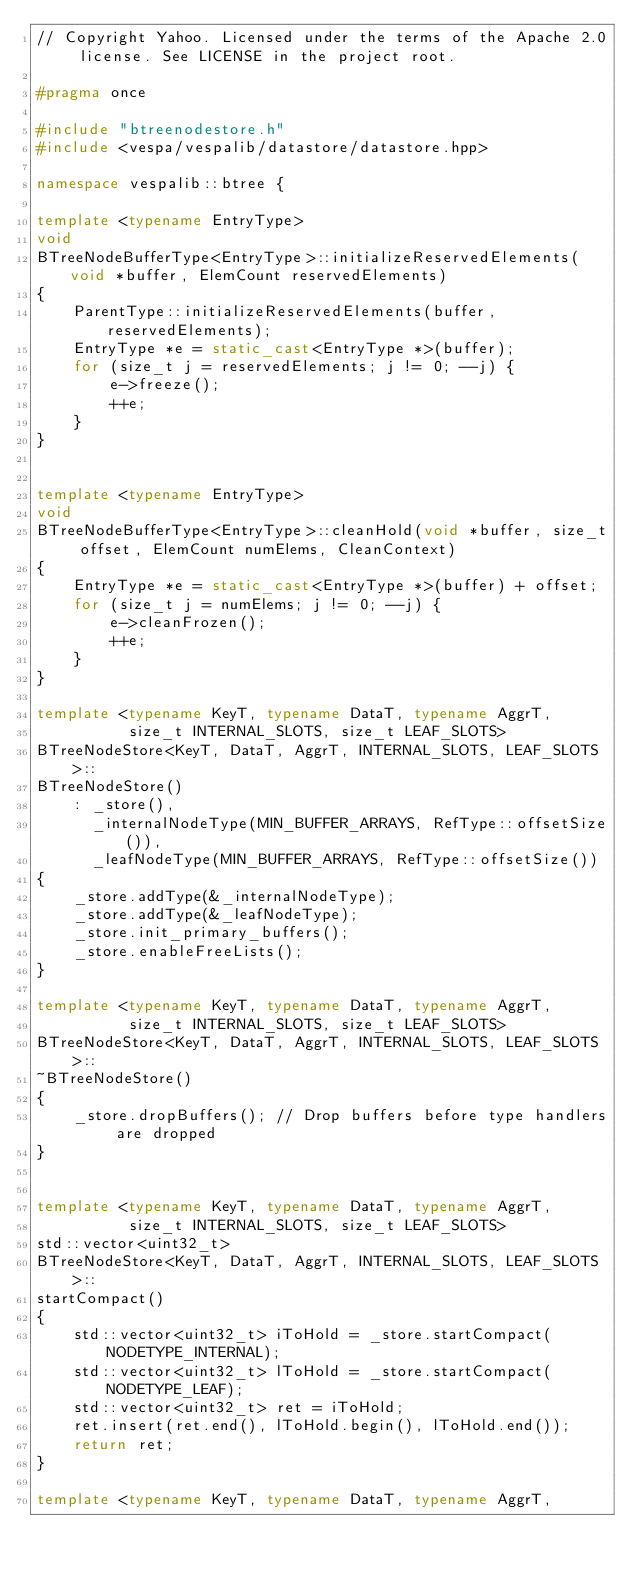Convert code to text. <code><loc_0><loc_0><loc_500><loc_500><_C++_>// Copyright Yahoo. Licensed under the terms of the Apache 2.0 license. See LICENSE in the project root.

#pragma once

#include "btreenodestore.h"
#include <vespa/vespalib/datastore/datastore.hpp>

namespace vespalib::btree {

template <typename EntryType>
void
BTreeNodeBufferType<EntryType>::initializeReservedElements(void *buffer, ElemCount reservedElements)
{
    ParentType::initializeReservedElements(buffer, reservedElements);
    EntryType *e = static_cast<EntryType *>(buffer);
    for (size_t j = reservedElements; j != 0; --j) {
        e->freeze();
        ++e;
    }
}


template <typename EntryType>
void
BTreeNodeBufferType<EntryType>::cleanHold(void *buffer, size_t offset, ElemCount numElems, CleanContext)
{
    EntryType *e = static_cast<EntryType *>(buffer) + offset;
    for (size_t j = numElems; j != 0; --j) {
        e->cleanFrozen();
        ++e;
    }
}

template <typename KeyT, typename DataT, typename AggrT,
          size_t INTERNAL_SLOTS, size_t LEAF_SLOTS>
BTreeNodeStore<KeyT, DataT, AggrT, INTERNAL_SLOTS, LEAF_SLOTS>::
BTreeNodeStore()
    : _store(),
      _internalNodeType(MIN_BUFFER_ARRAYS, RefType::offsetSize()),
      _leafNodeType(MIN_BUFFER_ARRAYS, RefType::offsetSize())
{
    _store.addType(&_internalNodeType);
    _store.addType(&_leafNodeType);
    _store.init_primary_buffers();
    _store.enableFreeLists();
}

template <typename KeyT, typename DataT, typename AggrT,
          size_t INTERNAL_SLOTS, size_t LEAF_SLOTS>
BTreeNodeStore<KeyT, DataT, AggrT, INTERNAL_SLOTS, LEAF_SLOTS>::
~BTreeNodeStore()
{
    _store.dropBuffers(); // Drop buffers before type handlers are dropped
}


template <typename KeyT, typename DataT, typename AggrT,
          size_t INTERNAL_SLOTS, size_t LEAF_SLOTS>
std::vector<uint32_t>
BTreeNodeStore<KeyT, DataT, AggrT, INTERNAL_SLOTS, LEAF_SLOTS>::
startCompact()
{
    std::vector<uint32_t> iToHold = _store.startCompact(NODETYPE_INTERNAL);
    std::vector<uint32_t> lToHold = _store.startCompact(NODETYPE_LEAF);
    std::vector<uint32_t> ret = iToHold;
    ret.insert(ret.end(), lToHold.begin(), lToHold.end());
    return ret;
}

template <typename KeyT, typename DataT, typename AggrT,</code> 